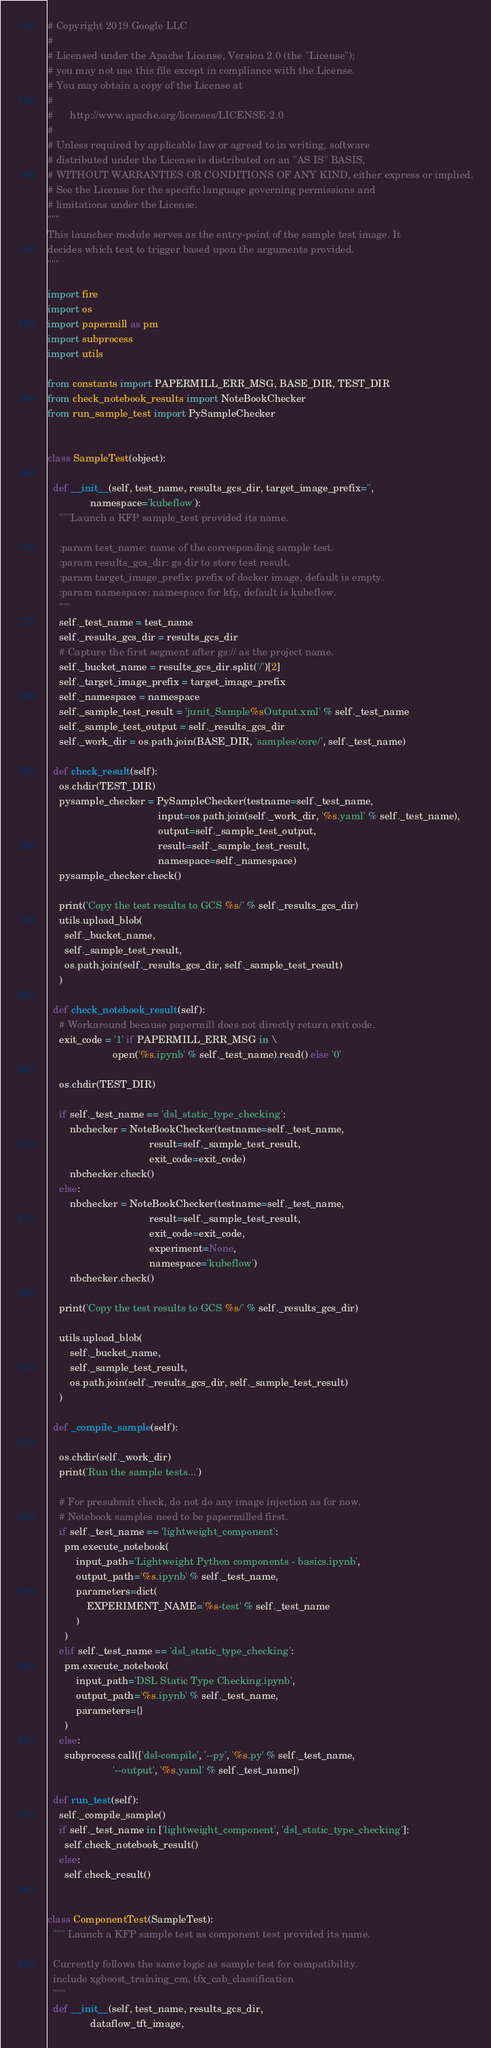Convert code to text. <code><loc_0><loc_0><loc_500><loc_500><_Python_># Copyright 2019 Google LLC
#
# Licensed under the Apache License, Version 2.0 (the "License");
# you may not use this file except in compliance with the License.
# You may obtain a copy of the License at
#
#      http://www.apache.org/licenses/LICENSE-2.0
#
# Unless required by applicable law or agreed to in writing, software
# distributed under the License is distributed on an "AS IS" BASIS,
# WITHOUT WARRANTIES OR CONDITIONS OF ANY KIND, either express or implied.
# See the License for the specific language governing permissions and
# limitations under the License.
"""
This launcher module serves as the entry-point of the sample test image. It
decides which test to trigger based upon the arguments provided.
"""

import fire
import os
import papermill as pm
import subprocess
import utils

from constants import PAPERMILL_ERR_MSG, BASE_DIR, TEST_DIR
from check_notebook_results import NoteBookChecker
from run_sample_test import PySampleChecker


class SampleTest(object):

  def __init__(self, test_name, results_gcs_dir, target_image_prefix='',
               namespace='kubeflow'):
    """Launch a KFP sample_test provided its name.

    :param test_name: name of the corresponding sample test.
    :param results_gcs_dir: gs dir to store test result.
    :param target_image_prefix: prefix of docker image, default is empty.
    :param namespace: namespace for kfp, default is kubeflow.
    """
    self._test_name = test_name
    self._results_gcs_dir = results_gcs_dir
    # Capture the first segment after gs:// as the project name.
    self._bucket_name = results_gcs_dir.split('/')[2]
    self._target_image_prefix = target_image_prefix
    self._namespace = namespace
    self._sample_test_result = 'junit_Sample%sOutput.xml' % self._test_name
    self._sample_test_output = self._results_gcs_dir
    self._work_dir = os.path.join(BASE_DIR, 'samples/core/', self._test_name)

  def check_result(self):
    os.chdir(TEST_DIR)
    pysample_checker = PySampleChecker(testname=self._test_name,
                                       input=os.path.join(self._work_dir, '%s.yaml' % self._test_name),
                                       output=self._sample_test_output,
                                       result=self._sample_test_result,
                                       namespace=self._namespace)
    pysample_checker.check()

    print('Copy the test results to GCS %s/' % self._results_gcs_dir)
    utils.upload_blob(
      self._bucket_name,
      self._sample_test_result,
      os.path.join(self._results_gcs_dir, self._sample_test_result)
    )

  def check_notebook_result(self):
    # Workaround because papermill does not directly return exit code.
    exit_code = '1' if PAPERMILL_ERR_MSG in \
                       open('%s.ipynb' % self._test_name).read() else '0'

    os.chdir(TEST_DIR)

    if self._test_name == 'dsl_static_type_checking':
        nbchecker = NoteBookChecker(testname=self._test_name,
                                    result=self._sample_test_result,
                                    exit_code=exit_code)
        nbchecker.check()
    else:
        nbchecker = NoteBookChecker(testname=self._test_name,
                                    result=self._sample_test_result,
                                    exit_code=exit_code,
                                    experiment=None,
                                    namespace='kubeflow')
        nbchecker.check()

    print('Copy the test results to GCS %s/' % self._results_gcs_dir)

    utils.upload_blob(
        self._bucket_name,
        self._sample_test_result,
        os.path.join(self._results_gcs_dir, self._sample_test_result)
    )

  def _compile_sample(self):

    os.chdir(self._work_dir)
    print('Run the sample tests...')

    # For presubmit check, do not do any image injection as for now.
    # Notebook samples need to be papermilled first.
    if self._test_name == 'lightweight_component':
      pm.execute_notebook(
          input_path='Lightweight Python components - basics.ipynb',
          output_path='%s.ipynb' % self._test_name,
          parameters=dict(
              EXPERIMENT_NAME='%s-test' % self._test_name
          )
      )
    elif self._test_name == 'dsl_static_type_checking':
      pm.execute_notebook(
          input_path='DSL Static Type Checking.ipynb',
          output_path='%s.ipynb' % self._test_name,
          parameters={}
      )
    else:
      subprocess.call(['dsl-compile', '--py', '%s.py' % self._test_name,
                       '--output', '%s.yaml' % self._test_name])

  def run_test(self):
    self._compile_sample()
    if self._test_name in ['lightweight_component', 'dsl_static_type_checking']:
      self.check_notebook_result()
    else:
      self.check_result()


class ComponentTest(SampleTest):
  """ Launch a KFP sample test as component test provided its name.

  Currently follows the same logic as sample test for compatibility.
  include xgboost_training_cm, tfx_cab_classification
  """
  def __init__(self, test_name, results_gcs_dir,
               dataflow_tft_image,</code> 